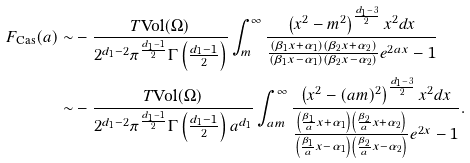Convert formula to latex. <formula><loc_0><loc_0><loc_500><loc_500>F _ { \text {Cas} } ( a ) \sim & - \frac { T \text {Vol} ( \Omega ) } { 2 ^ { d _ { 1 } - 2 } \pi ^ { \frac { d _ { 1 } - 1 } { 2 } } \Gamma \left ( \frac { d _ { 1 } - 1 } { 2 } \right ) } \int _ { m } ^ { \infty } \frac { \left ( x ^ { 2 } - m ^ { 2 } \right ) ^ { \frac { d _ { 1 } - 3 } { 2 } } x ^ { 2 } d x } { \frac { ( \beta _ { 1 } x + \alpha _ { 1 } ) ( \beta _ { 2 } x + \alpha _ { 2 } ) } { ( \beta _ { 1 } x - \alpha _ { 1 } ) ( \beta _ { 2 } x - \alpha _ { 2 } ) } e ^ { 2 a x } - 1 } \\ \sim & - \frac { T \text {Vol} ( \Omega ) } { 2 ^ { d _ { 1 } - 2 } \pi ^ { \frac { d _ { 1 } - 1 } { 2 } } \Gamma \left ( \frac { d _ { 1 } - 1 } { 2 } \right ) a ^ { d _ { 1 } } } \int _ { a m } ^ { \infty } \frac { \left ( x ^ { 2 } - ( a m ) ^ { 2 } \right ) ^ { \frac { d _ { 1 } - 3 } { 2 } } x ^ { 2 } d x } { \frac { \left ( \frac { \beta _ { 1 } } { a } x + \alpha _ { 1 } \right ) \left ( \frac { \beta _ { 2 } } { a } x + \alpha _ { 2 } \right ) } { \left ( \frac { \beta _ { 1 } } { a } x - \alpha _ { 1 } \right ) \left ( \frac { \beta _ { 2 } } { a } x - \alpha _ { 2 } \right ) } e ^ { 2 x } - 1 } .</formula> 